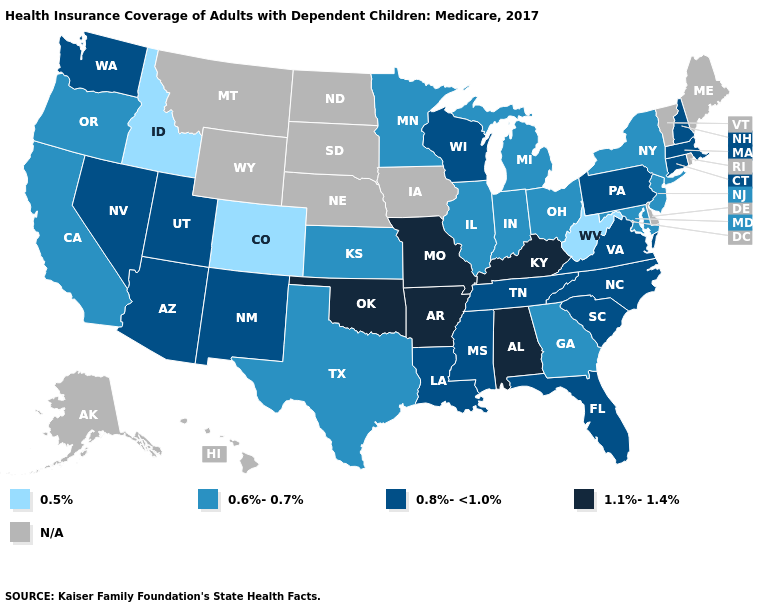Among the states that border Maine , which have the highest value?
Give a very brief answer. New Hampshire. What is the lowest value in the USA?
Short answer required. 0.5%. Does Louisiana have the lowest value in the USA?
Give a very brief answer. No. Name the states that have a value in the range 0.5%?
Quick response, please. Colorado, Idaho, West Virginia. Is the legend a continuous bar?
Be succinct. No. What is the value of Louisiana?
Keep it brief. 0.8%-<1.0%. Name the states that have a value in the range 0.8%-<1.0%?
Write a very short answer. Arizona, Connecticut, Florida, Louisiana, Massachusetts, Mississippi, Nevada, New Hampshire, New Mexico, North Carolina, Pennsylvania, South Carolina, Tennessee, Utah, Virginia, Washington, Wisconsin. Name the states that have a value in the range 0.8%-<1.0%?
Short answer required. Arizona, Connecticut, Florida, Louisiana, Massachusetts, Mississippi, Nevada, New Hampshire, New Mexico, North Carolina, Pennsylvania, South Carolina, Tennessee, Utah, Virginia, Washington, Wisconsin. What is the value of Kentucky?
Give a very brief answer. 1.1%-1.4%. What is the highest value in states that border New Hampshire?
Quick response, please. 0.8%-<1.0%. Does Indiana have the highest value in the MidWest?
Answer briefly. No. What is the lowest value in states that border North Dakota?
Answer briefly. 0.6%-0.7%. What is the value of Wisconsin?
Be succinct. 0.8%-<1.0%. 